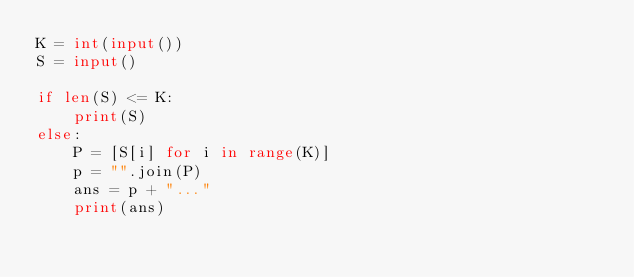Convert code to text. <code><loc_0><loc_0><loc_500><loc_500><_Python_>K = int(input())
S = input()

if len(S) <= K:
    print(S)
else:
    P = [S[i] for i in range(K)]
    p = "".join(P)
    ans = p + "..."
    print(ans)
</code> 